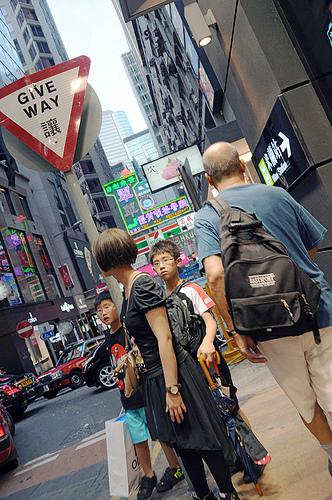Question: who has a backpack on their back?
Choices:
A. The dog.
B. The man.
C. The woman.
D. The child.
Answer with the letter. Answer: B Question: what color is the woman's dress?
Choices:
A. Red.
B. Black.
C. Yellow.
D. White.
Answer with the letter. Answer: B Question: why are the people waiting?
Choices:
A. Weather.
B. Waiting in long lines.
C. Traffic.
D. They are lost.
Answer with the letter. Answer: C Question: what are both boys wearing on their faces?
Choices:
A. Makeup.
B. Glasses.
C. Masks.
D. Fake beards.
Answer with the letter. Answer: B 